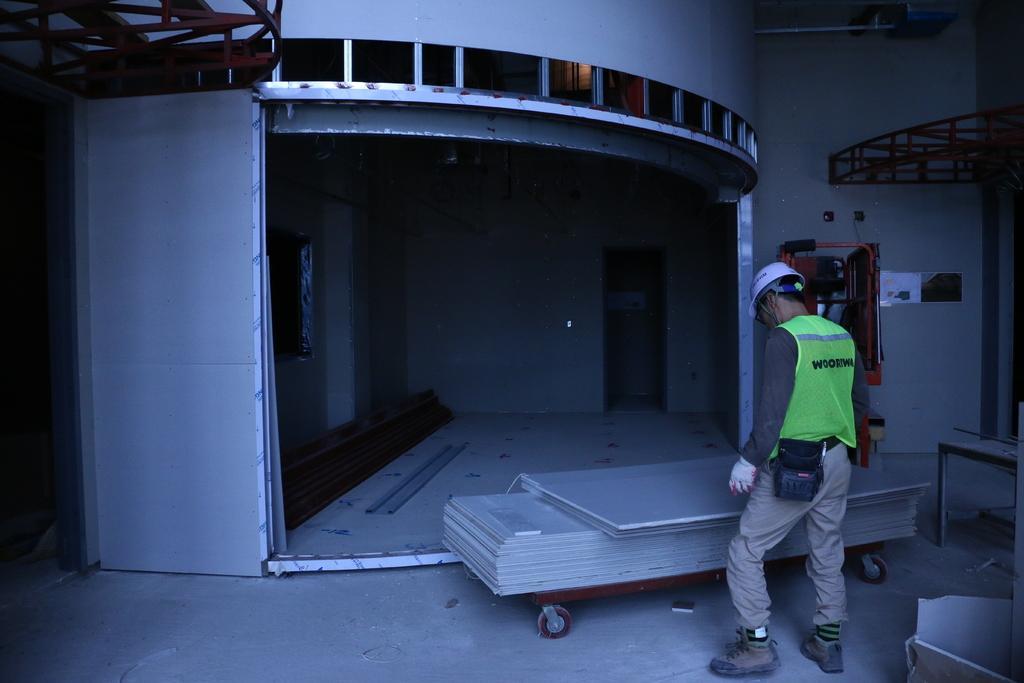Describe this image in one or two sentences. In this image there is a man standing. In front of him there are objects on the trolley. In the background there is a door to the wall. To the right there are machines. 